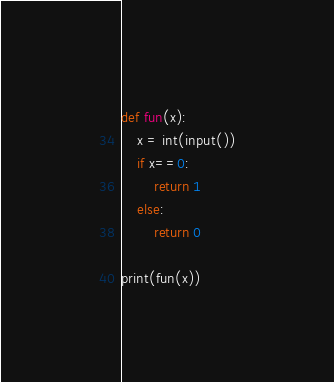Convert code to text. <code><loc_0><loc_0><loc_500><loc_500><_Python_>def fun(x):
    x = int(input())
    if x==0:
        return 1
    else:
        return 0

print(fun(x))</code> 